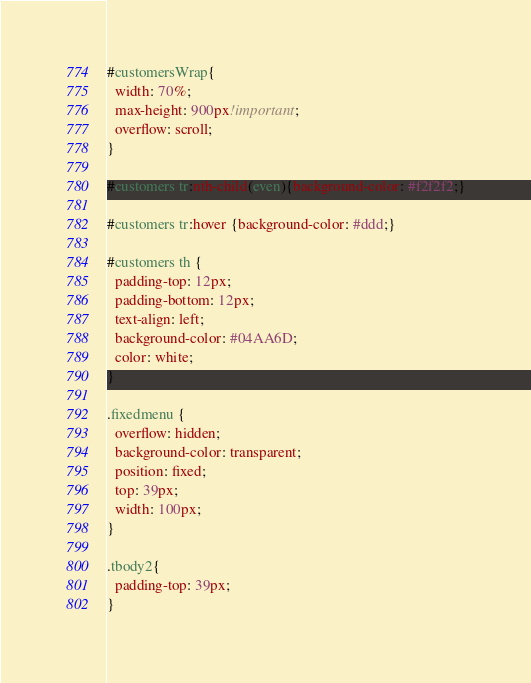<code> <loc_0><loc_0><loc_500><loc_500><_CSS_>#customersWrap{
  width: 70%;
  max-height: 900px!important;
  overflow: scroll;
}

#customers tr:nth-child(even){background-color: #f2f2f2;}

#customers tr:hover {background-color: #ddd;}

#customers th {
  padding-top: 12px;
  padding-bottom: 12px;
  text-align: left;
  background-color: #04AA6D;
  color: white;
}

.fixedmenu {
  overflow: hidden;
  background-color: transparent;
  position: fixed;
  top: 39px;
  width: 100px;
}

.tbody2{
  padding-top: 39px;
}</code> 